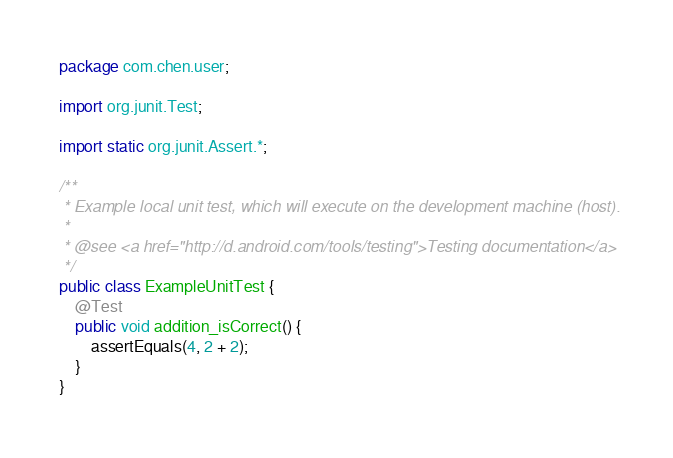<code> <loc_0><loc_0><loc_500><loc_500><_Java_>package com.chen.user;

import org.junit.Test;

import static org.junit.Assert.*;

/**
 * Example local unit test, which will execute on the development machine (host).
 *
 * @see <a href="http://d.android.com/tools/testing">Testing documentation</a>
 */
public class ExampleUnitTest {
    @Test
    public void addition_isCorrect() {
        assertEquals(4, 2 + 2);
    }
}</code> 